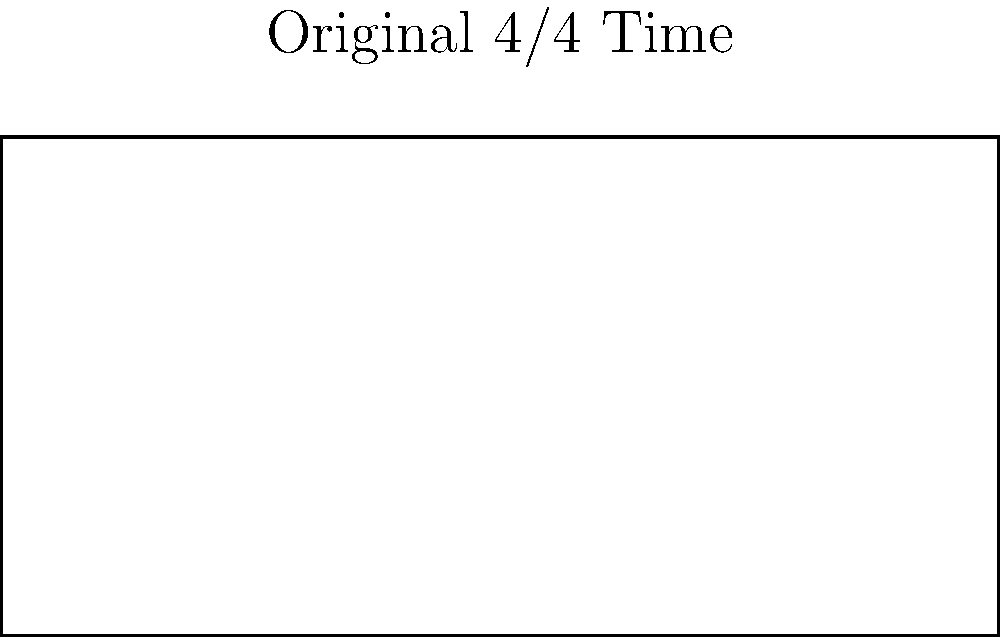In your gospel choir rehearsal, you need to adapt a piece of sheet music from 4/4 time to 3/4 time while maintaining the same note durations. If the original sheet music measures 100 units in width, what will be the width of the scaled version to fit the new time signature? To solve this problem, we need to follow these steps:

1. Understand the relationship between the time signatures:
   - 4/4 time has 4 beats per measure
   - 3/4 time has 3 beats per measure

2. Calculate the scaling factor:
   - Scaling factor = New time signature / Original time signature
   - Scaling factor = 3/4 ÷ 4/4 = 3/4 = 0.75

3. Apply the scaling factor to the original width:
   - Original width = 100 units
   - New width = Original width × Scaling factor
   - New width = 100 × 0.75 = 75 units

The scaled version of the sheet music will have a width of 75 units to fit the new 3/4 time signature while maintaining the same note durations.
Answer: 75 units 